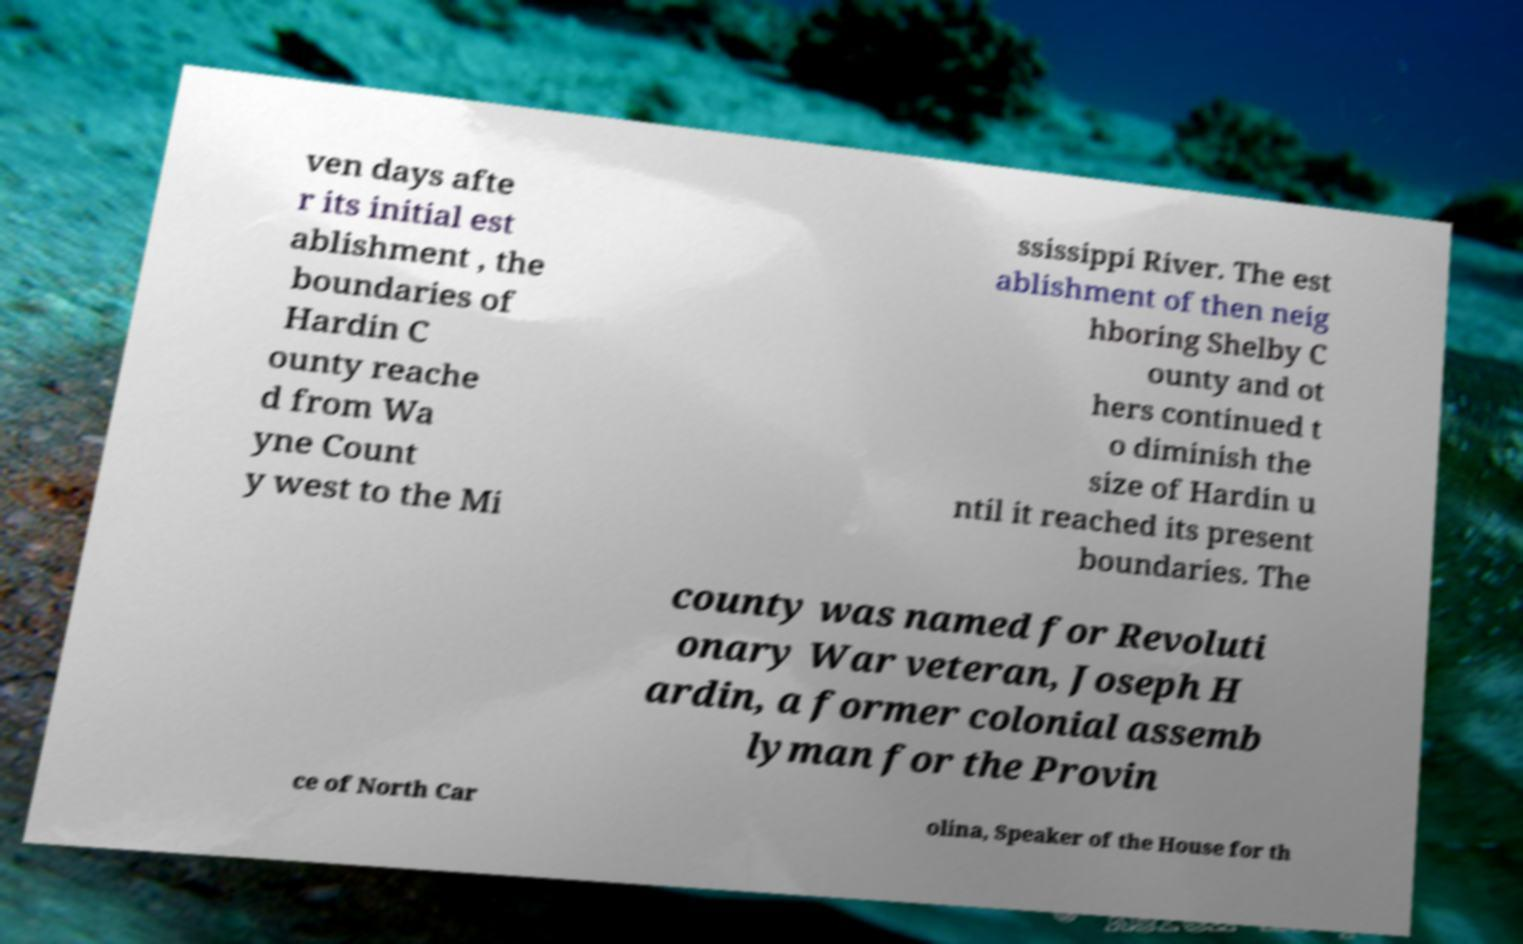There's text embedded in this image that I need extracted. Can you transcribe it verbatim? ven days afte r its initial est ablishment , the boundaries of Hardin C ounty reache d from Wa yne Count y west to the Mi ssissippi River. The est ablishment of then neig hboring Shelby C ounty and ot hers continued t o diminish the size of Hardin u ntil it reached its present boundaries. The county was named for Revoluti onary War veteran, Joseph H ardin, a former colonial assemb lyman for the Provin ce of North Car olina, Speaker of the House for th 